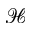<formula> <loc_0><loc_0><loc_500><loc_500>\mathcal { H }</formula> 